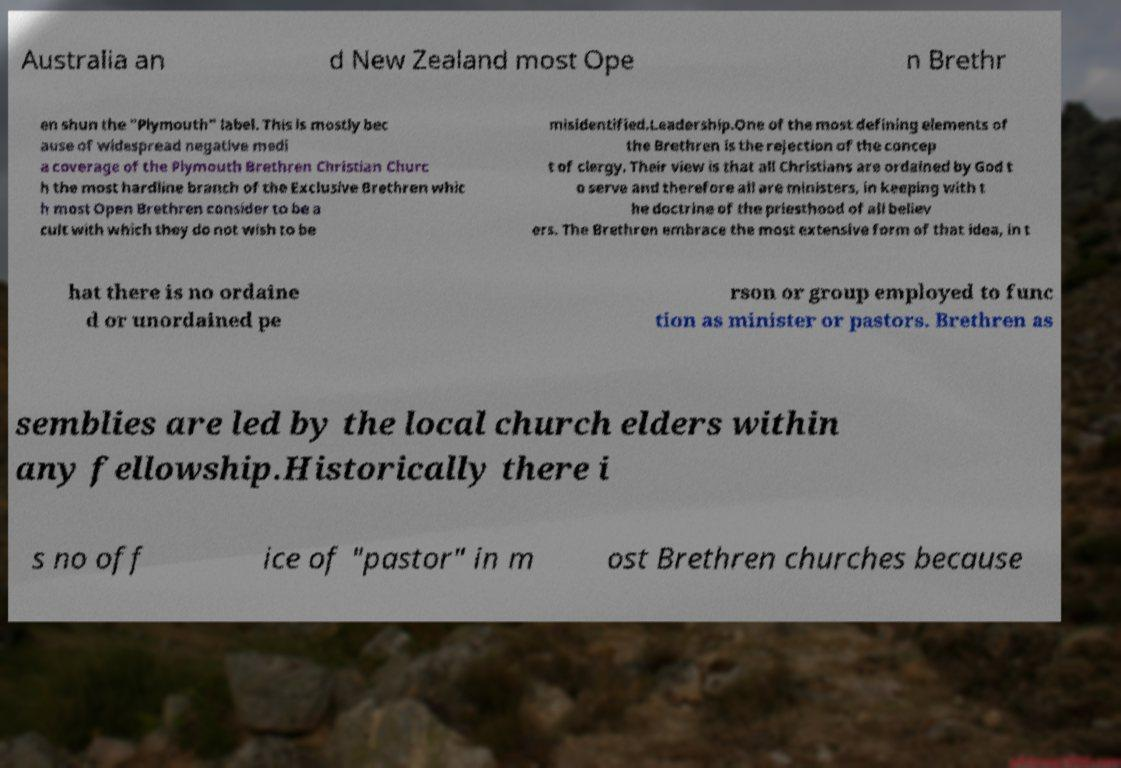Could you assist in decoding the text presented in this image and type it out clearly? Australia an d New Zealand most Ope n Brethr en shun the "Plymouth" label. This is mostly bec ause of widespread negative medi a coverage of the Plymouth Brethren Christian Churc h the most hardline branch of the Exclusive Brethren whic h most Open Brethren consider to be a cult with which they do not wish to be misidentified.Leadership.One of the most defining elements of the Brethren is the rejection of the concep t of clergy. Their view is that all Christians are ordained by God t o serve and therefore all are ministers, in keeping with t he doctrine of the priesthood of all believ ers. The Brethren embrace the most extensive form of that idea, in t hat there is no ordaine d or unordained pe rson or group employed to func tion as minister or pastors. Brethren as semblies are led by the local church elders within any fellowship.Historically there i s no off ice of "pastor" in m ost Brethren churches because 